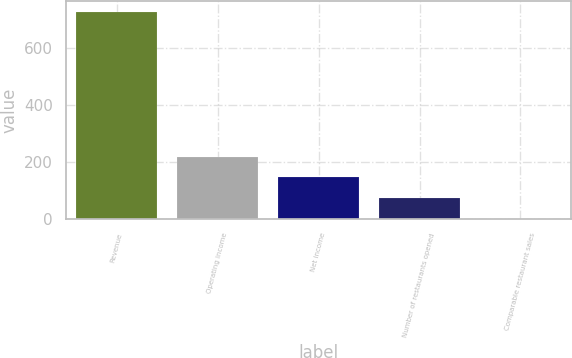Convert chart to OTSL. <chart><loc_0><loc_0><loc_500><loc_500><bar_chart><fcel>Revenue<fcel>Operating income<fcel>Net income<fcel>Number of restaurants opened<fcel>Comparable restaurant sales<nl><fcel>726.8<fcel>218.74<fcel>146.16<fcel>73.58<fcel>1<nl></chart> 